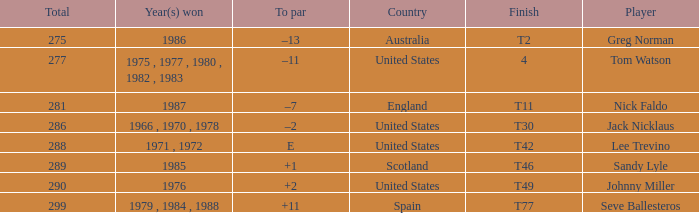What's england's to par? –7. 